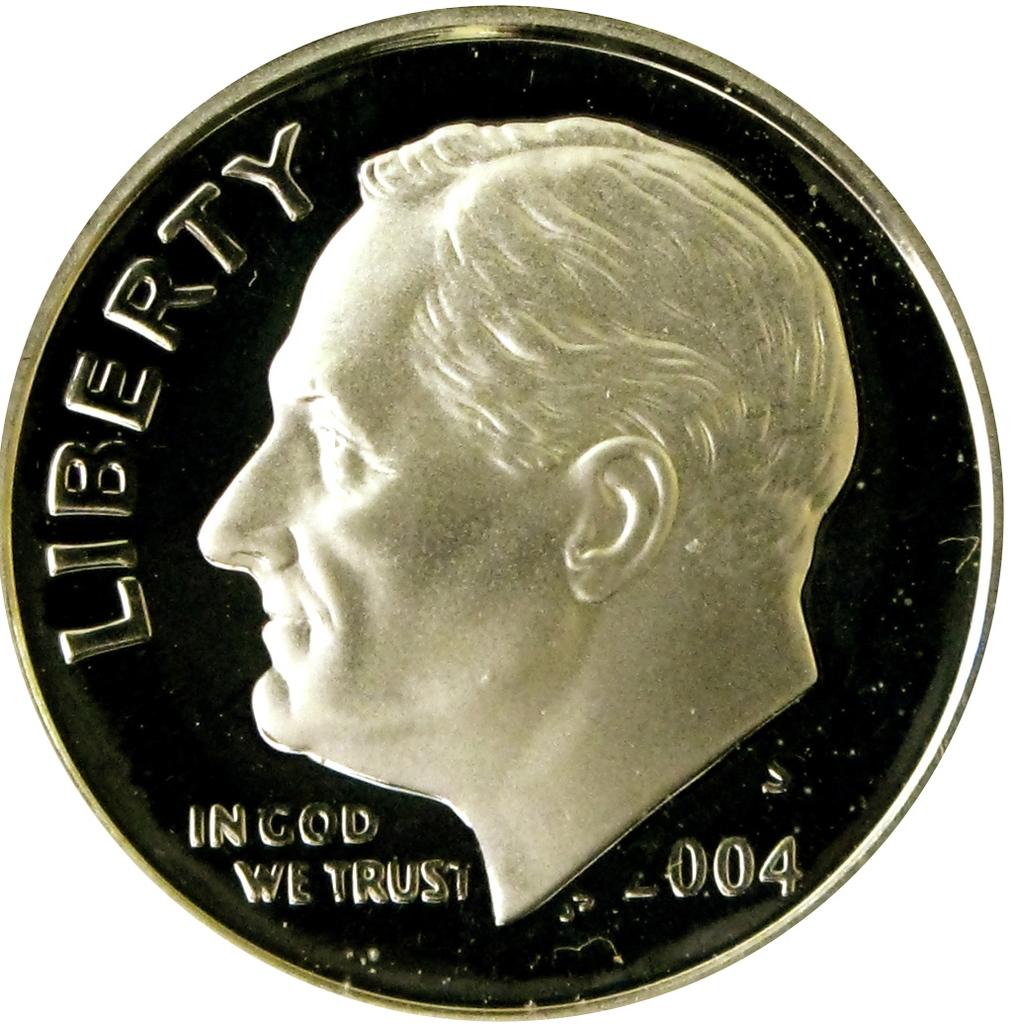What does this reminds you?
Provide a succinct answer. In god we trust. What year is on the coin?
Give a very brief answer. 2004. 